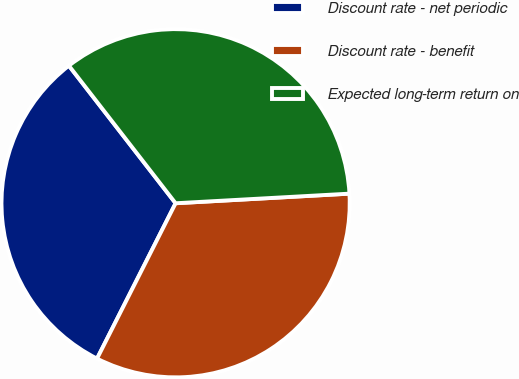Convert chart to OTSL. <chart><loc_0><loc_0><loc_500><loc_500><pie_chart><fcel>Discount rate - net periodic<fcel>Discount rate - benefit<fcel>Expected long-term return on<nl><fcel>32.05%<fcel>33.33%<fcel>34.62%<nl></chart> 